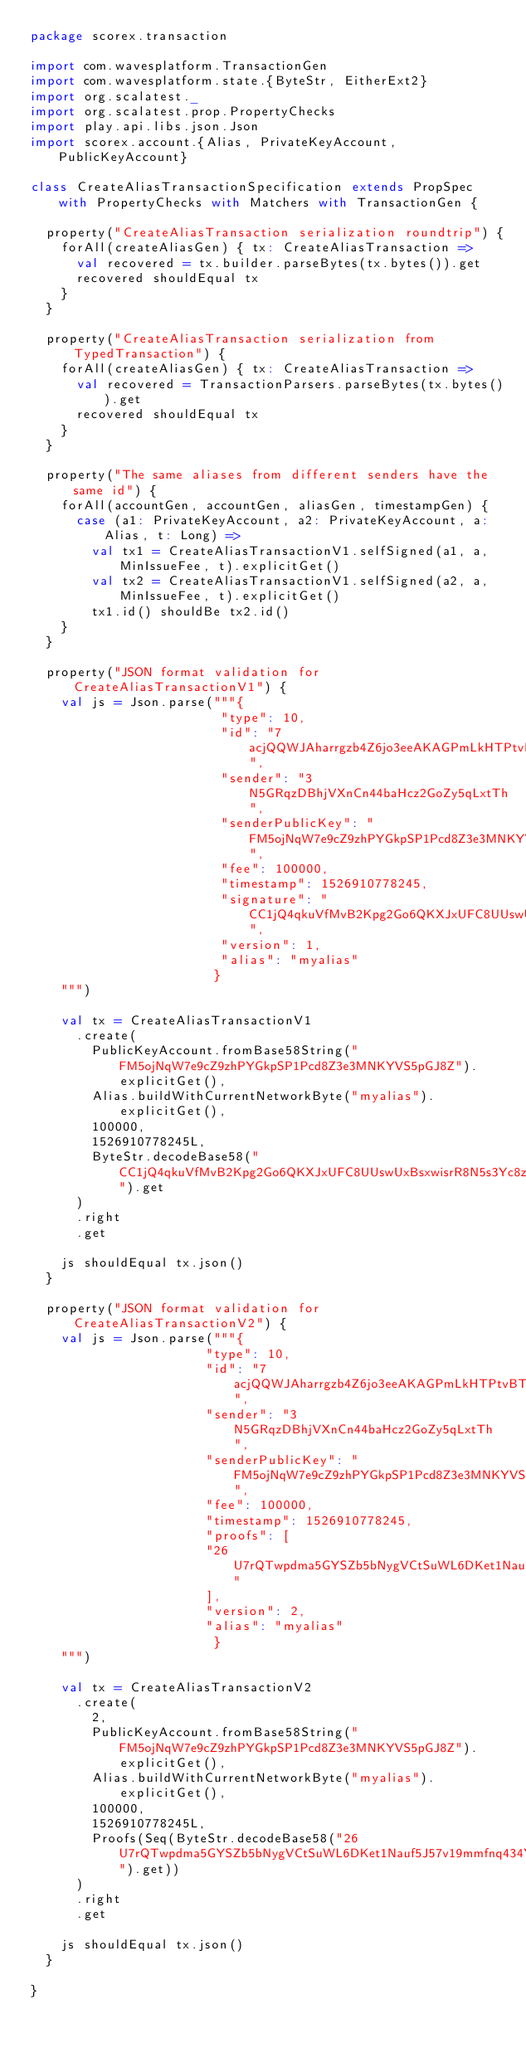<code> <loc_0><loc_0><loc_500><loc_500><_Scala_>package scorex.transaction

import com.wavesplatform.TransactionGen
import com.wavesplatform.state.{ByteStr, EitherExt2}
import org.scalatest._
import org.scalatest.prop.PropertyChecks
import play.api.libs.json.Json
import scorex.account.{Alias, PrivateKeyAccount, PublicKeyAccount}

class CreateAliasTransactionSpecification extends PropSpec with PropertyChecks with Matchers with TransactionGen {

  property("CreateAliasTransaction serialization roundtrip") {
    forAll(createAliasGen) { tx: CreateAliasTransaction =>
      val recovered = tx.builder.parseBytes(tx.bytes()).get
      recovered shouldEqual tx
    }
  }

  property("CreateAliasTransaction serialization from TypedTransaction") {
    forAll(createAliasGen) { tx: CreateAliasTransaction =>
      val recovered = TransactionParsers.parseBytes(tx.bytes()).get
      recovered shouldEqual tx
    }
  }

  property("The same aliases from different senders have the same id") {
    forAll(accountGen, accountGen, aliasGen, timestampGen) {
      case (a1: PrivateKeyAccount, a2: PrivateKeyAccount, a: Alias, t: Long) =>
        val tx1 = CreateAliasTransactionV1.selfSigned(a1, a, MinIssueFee, t).explicitGet()
        val tx2 = CreateAliasTransactionV1.selfSigned(a2, a, MinIssueFee, t).explicitGet()
        tx1.id() shouldBe tx2.id()
    }
  }

  property("JSON format validation for CreateAliasTransactionV1") {
    val js = Json.parse("""{
                         "type": 10,
                         "id": "7acjQQWJAharrgzb4Z6jo3eeAKAGPmLkHTPtvBTKaiug",
                         "sender": "3N5GRqzDBhjVXnCn44baHcz2GoZy5qLxtTh",
                         "senderPublicKey": "FM5ojNqW7e9cZ9zhPYGkpSP1Pcd8Z3e3MNKYVS5pGJ8Z",
                         "fee": 100000,
                         "timestamp": 1526910778245,
                         "signature": "CC1jQ4qkuVfMvB2Kpg2Go6QKXJxUFC8UUswUxBsxwisrR8N5s3Yc8zA6dhjTwfWKfdouSTAnRXCxTXb3T6pJq3T",
                         "version": 1,
                         "alias": "myalias"
                        }
    """)

    val tx = CreateAliasTransactionV1
      .create(
        PublicKeyAccount.fromBase58String("FM5ojNqW7e9cZ9zhPYGkpSP1Pcd8Z3e3MNKYVS5pGJ8Z").explicitGet(),
        Alias.buildWithCurrentNetworkByte("myalias").explicitGet(),
        100000,
        1526910778245L,
        ByteStr.decodeBase58("CC1jQ4qkuVfMvB2Kpg2Go6QKXJxUFC8UUswUxBsxwisrR8N5s3Yc8zA6dhjTwfWKfdouSTAnRXCxTXb3T6pJq3T").get
      )
      .right
      .get

    js shouldEqual tx.json()
  }

  property("JSON format validation for CreateAliasTransactionV2") {
    val js = Json.parse("""{
                       "type": 10,
                       "id": "7acjQQWJAharrgzb4Z6jo3eeAKAGPmLkHTPtvBTKaiug",
                       "sender": "3N5GRqzDBhjVXnCn44baHcz2GoZy5qLxtTh",
                       "senderPublicKey": "FM5ojNqW7e9cZ9zhPYGkpSP1Pcd8Z3e3MNKYVS5pGJ8Z",
                       "fee": 100000,
                       "timestamp": 1526910778245,
                       "proofs": [
                       "26U7rQTwpdma5GYSZb5bNygVCtSuWL6DKet1Nauf5J57v19mmfnq434YrkKYJqvYt2ydQBUT3P7Xgj5ZVDVAcc5k"
                       ],
                       "version": 2,
                       "alias": "myalias"
                        }
    """)

    val tx = CreateAliasTransactionV2
      .create(
        2,
        PublicKeyAccount.fromBase58String("FM5ojNqW7e9cZ9zhPYGkpSP1Pcd8Z3e3MNKYVS5pGJ8Z").explicitGet(),
        Alias.buildWithCurrentNetworkByte("myalias").explicitGet(),
        100000,
        1526910778245L,
        Proofs(Seq(ByteStr.decodeBase58("26U7rQTwpdma5GYSZb5bNygVCtSuWL6DKet1Nauf5J57v19mmfnq434YrkKYJqvYt2ydQBUT3P7Xgj5ZVDVAcc5k").get))
      )
      .right
      .get

    js shouldEqual tx.json()
  }

}
</code> 